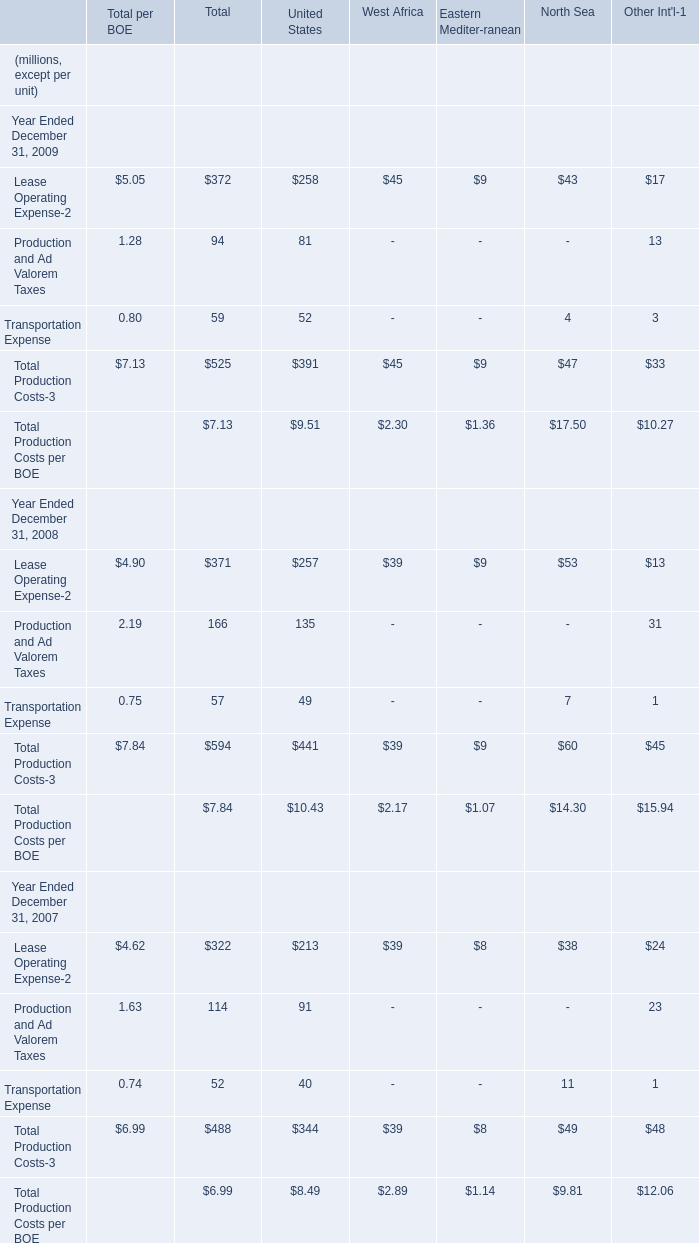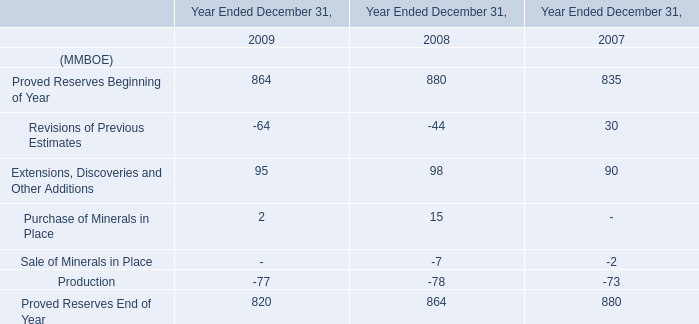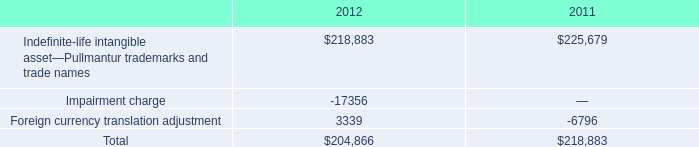What's the average of Lease Operating Expense-2 in 2009? (in million) 
Computations: (((((((5.05 + 372) + 258) + 45) + 9) + 43) + 17) / 7)
Answer: 107.00714. 